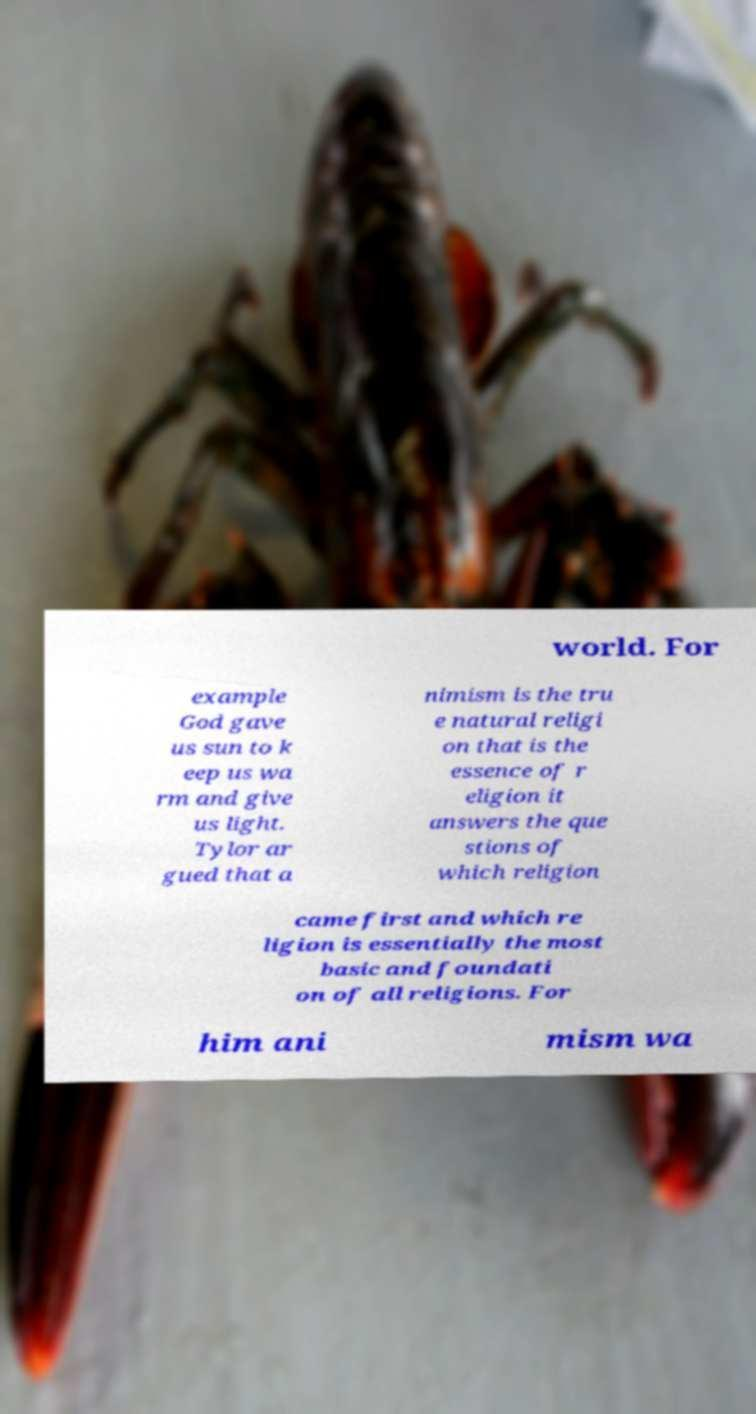Please read and relay the text visible in this image. What does it say? world. For example God gave us sun to k eep us wa rm and give us light. Tylor ar gued that a nimism is the tru e natural religi on that is the essence of r eligion it answers the que stions of which religion came first and which re ligion is essentially the most basic and foundati on of all religions. For him ani mism wa 